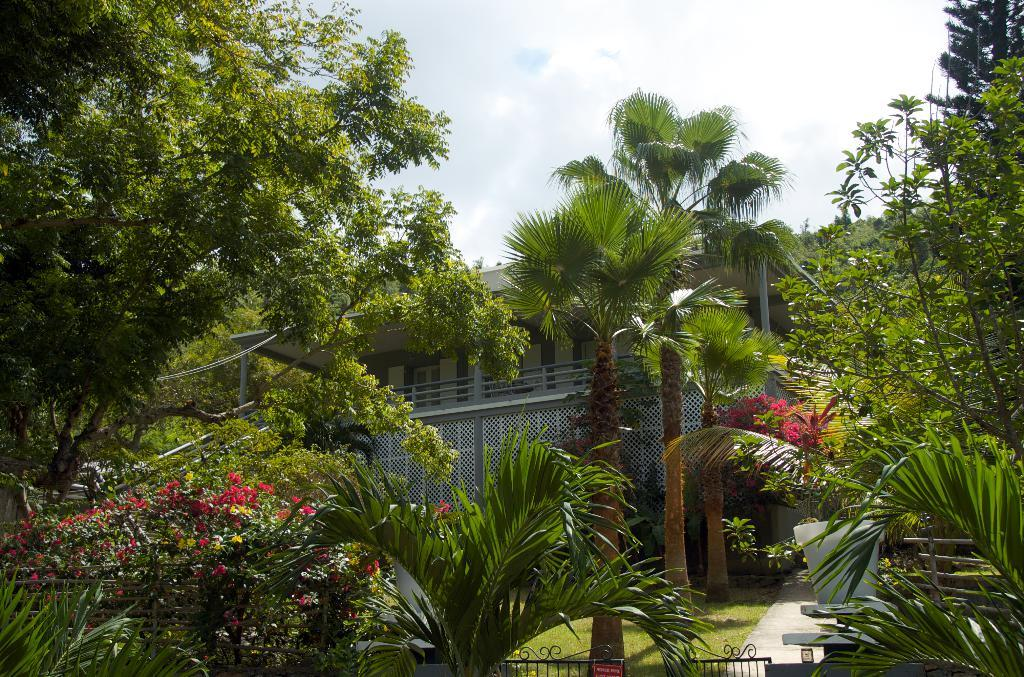What type of structure is visible in the image? There is a house in the image. What type of vegetation can be seen in the image? There are trees and plants in the image. What is the entrance to the house like in the image? There is a gate at the bottom of the image. What is visible at the top of the image? The sky is visible at the top of the image. What can be seen in the sky in the image? There are clouds in the sky. Where are the tomatoes growing in the image? There are no tomatoes present in the image. What type of pet can be seen playing near the house in the image? There is no pet visible in the image. 